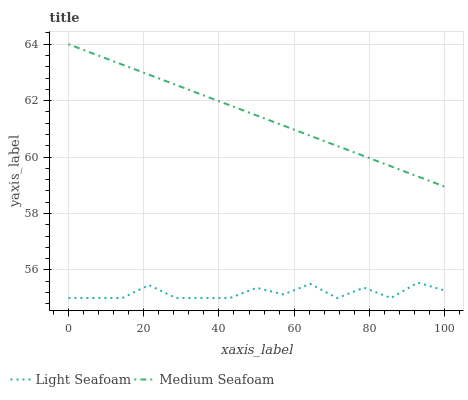Does Light Seafoam have the minimum area under the curve?
Answer yes or no. Yes. Does Medium Seafoam have the maximum area under the curve?
Answer yes or no. Yes. Does Medium Seafoam have the minimum area under the curve?
Answer yes or no. No. Is Medium Seafoam the smoothest?
Answer yes or no. Yes. Is Light Seafoam the roughest?
Answer yes or no. Yes. Is Medium Seafoam the roughest?
Answer yes or no. No. Does Light Seafoam have the lowest value?
Answer yes or no. Yes. Does Medium Seafoam have the lowest value?
Answer yes or no. No. Does Medium Seafoam have the highest value?
Answer yes or no. Yes. Is Light Seafoam less than Medium Seafoam?
Answer yes or no. Yes. Is Medium Seafoam greater than Light Seafoam?
Answer yes or no. Yes. Does Light Seafoam intersect Medium Seafoam?
Answer yes or no. No. 